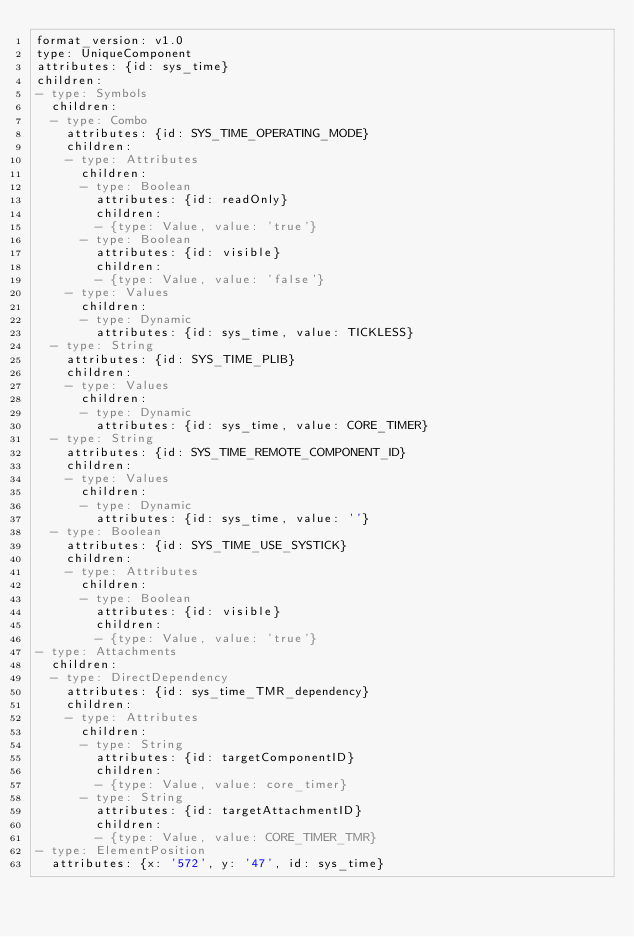Convert code to text. <code><loc_0><loc_0><loc_500><loc_500><_YAML_>format_version: v1.0
type: UniqueComponent
attributes: {id: sys_time}
children:
- type: Symbols
  children:
  - type: Combo
    attributes: {id: SYS_TIME_OPERATING_MODE}
    children:
    - type: Attributes
      children:
      - type: Boolean
        attributes: {id: readOnly}
        children:
        - {type: Value, value: 'true'}
      - type: Boolean
        attributes: {id: visible}
        children:
        - {type: Value, value: 'false'}
    - type: Values
      children:
      - type: Dynamic
        attributes: {id: sys_time, value: TICKLESS}
  - type: String
    attributes: {id: SYS_TIME_PLIB}
    children:
    - type: Values
      children:
      - type: Dynamic
        attributes: {id: sys_time, value: CORE_TIMER}
  - type: String
    attributes: {id: SYS_TIME_REMOTE_COMPONENT_ID}
    children:
    - type: Values
      children:
      - type: Dynamic
        attributes: {id: sys_time, value: ''}
  - type: Boolean
    attributes: {id: SYS_TIME_USE_SYSTICK}
    children:
    - type: Attributes
      children:
      - type: Boolean
        attributes: {id: visible}
        children:
        - {type: Value, value: 'true'}
- type: Attachments
  children:
  - type: DirectDependency
    attributes: {id: sys_time_TMR_dependency}
    children:
    - type: Attributes
      children:
      - type: String
        attributes: {id: targetComponentID}
        children:
        - {type: Value, value: core_timer}
      - type: String
        attributes: {id: targetAttachmentID}
        children:
        - {type: Value, value: CORE_TIMER_TMR}
- type: ElementPosition
  attributes: {x: '572', y: '47', id: sys_time}
</code> 